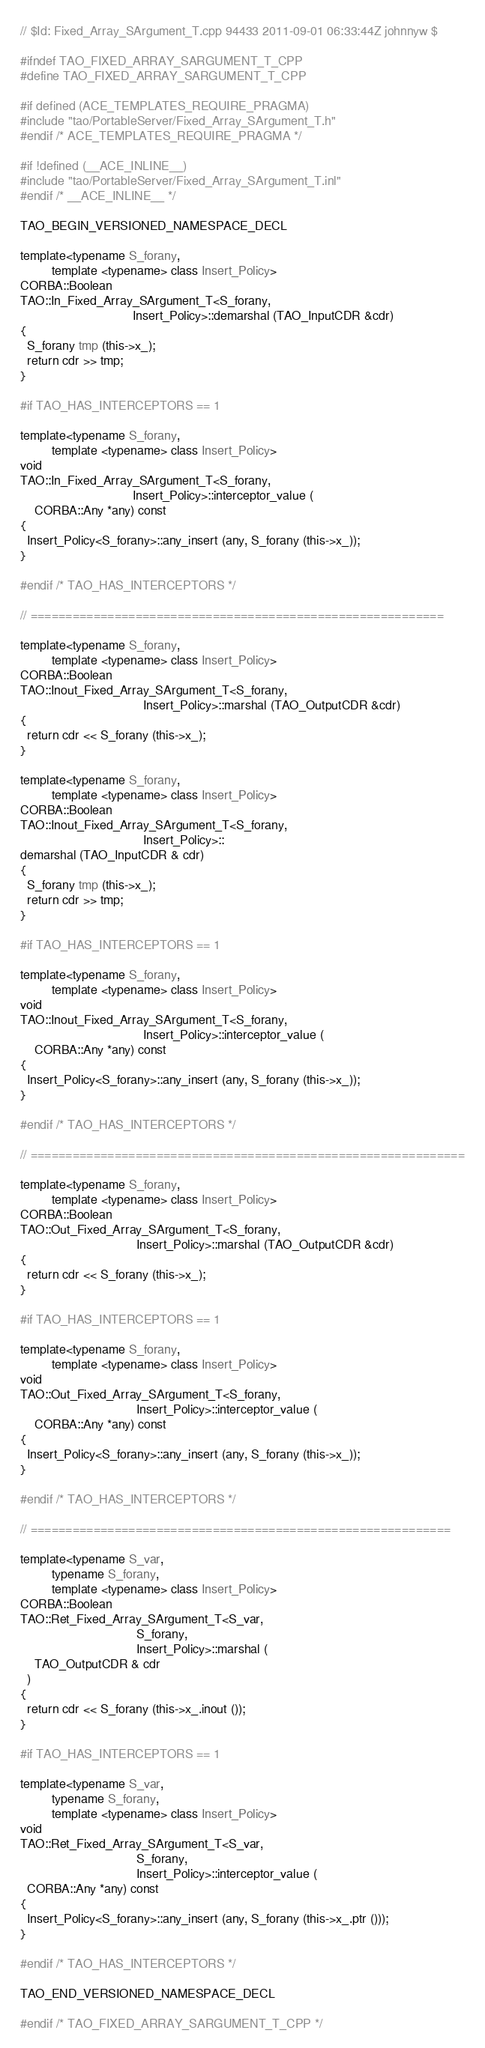<code> <loc_0><loc_0><loc_500><loc_500><_C++_>// $Id: Fixed_Array_SArgument_T.cpp 94433 2011-09-01 06:33:44Z johnnyw $

#ifndef TAO_FIXED_ARRAY_SARGUMENT_T_CPP
#define TAO_FIXED_ARRAY_SARGUMENT_T_CPP

#if defined (ACE_TEMPLATES_REQUIRE_PRAGMA)
#include "tao/PortableServer/Fixed_Array_SArgument_T.h"
#endif /* ACE_TEMPLATES_REQUIRE_PRAGMA */

#if !defined (__ACE_INLINE__)
#include "tao/PortableServer/Fixed_Array_SArgument_T.inl"
#endif /* __ACE_INLINE__ */

TAO_BEGIN_VERSIONED_NAMESPACE_DECL

template<typename S_forany,
         template <typename> class Insert_Policy>
CORBA::Boolean
TAO::In_Fixed_Array_SArgument_T<S_forany,
                                Insert_Policy>::demarshal (TAO_InputCDR &cdr)
{
  S_forany tmp (this->x_);
  return cdr >> tmp;
}

#if TAO_HAS_INTERCEPTORS == 1

template<typename S_forany,
         template <typename> class Insert_Policy>
void
TAO::In_Fixed_Array_SArgument_T<S_forany,
                                Insert_Policy>::interceptor_value (
    CORBA::Any *any) const
{
  Insert_Policy<S_forany>::any_insert (any, S_forany (this->x_));
}

#endif /* TAO_HAS_INTERCEPTORS */

// ===========================================================

template<typename S_forany,
         template <typename> class Insert_Policy>
CORBA::Boolean
TAO::Inout_Fixed_Array_SArgument_T<S_forany,
                                   Insert_Policy>::marshal (TAO_OutputCDR &cdr)
{
  return cdr << S_forany (this->x_);
}

template<typename S_forany,
         template <typename> class Insert_Policy>
CORBA::Boolean
TAO::Inout_Fixed_Array_SArgument_T<S_forany,
                                   Insert_Policy>::
demarshal (TAO_InputCDR & cdr)
{
  S_forany tmp (this->x_);
  return cdr >> tmp;
}

#if TAO_HAS_INTERCEPTORS == 1

template<typename S_forany,
         template <typename> class Insert_Policy>
void
TAO::Inout_Fixed_Array_SArgument_T<S_forany,
                                   Insert_Policy>::interceptor_value (
    CORBA::Any *any) const
{
  Insert_Policy<S_forany>::any_insert (any, S_forany (this->x_));
}

#endif /* TAO_HAS_INTERCEPTORS */

// ==============================================================

template<typename S_forany,
         template <typename> class Insert_Policy>
CORBA::Boolean
TAO::Out_Fixed_Array_SArgument_T<S_forany,
                                 Insert_Policy>::marshal (TAO_OutputCDR &cdr)
{
  return cdr << S_forany (this->x_);
}

#if TAO_HAS_INTERCEPTORS == 1

template<typename S_forany,
         template <typename> class Insert_Policy>
void
TAO::Out_Fixed_Array_SArgument_T<S_forany,
                                 Insert_Policy>::interceptor_value (
    CORBA::Any *any) const
{
  Insert_Policy<S_forany>::any_insert (any, S_forany (this->x_));
}

#endif /* TAO_HAS_INTERCEPTORS */

// ============================================================

template<typename S_var,
         typename S_forany,
         template <typename> class Insert_Policy>
CORBA::Boolean
TAO::Ret_Fixed_Array_SArgument_T<S_var,
                                 S_forany,
                                 Insert_Policy>::marshal (
    TAO_OutputCDR & cdr
  )
{
  return cdr << S_forany (this->x_.inout ());
}

#if TAO_HAS_INTERCEPTORS == 1

template<typename S_var,
         typename S_forany,
         template <typename> class Insert_Policy>
void
TAO::Ret_Fixed_Array_SArgument_T<S_var,
                                 S_forany,
                                 Insert_Policy>::interceptor_value (
  CORBA::Any *any) const
{
  Insert_Policy<S_forany>::any_insert (any, S_forany (this->x_.ptr ()));
}

#endif /* TAO_HAS_INTERCEPTORS */

TAO_END_VERSIONED_NAMESPACE_DECL

#endif /* TAO_FIXED_ARRAY_SARGUMENT_T_CPP */
</code> 